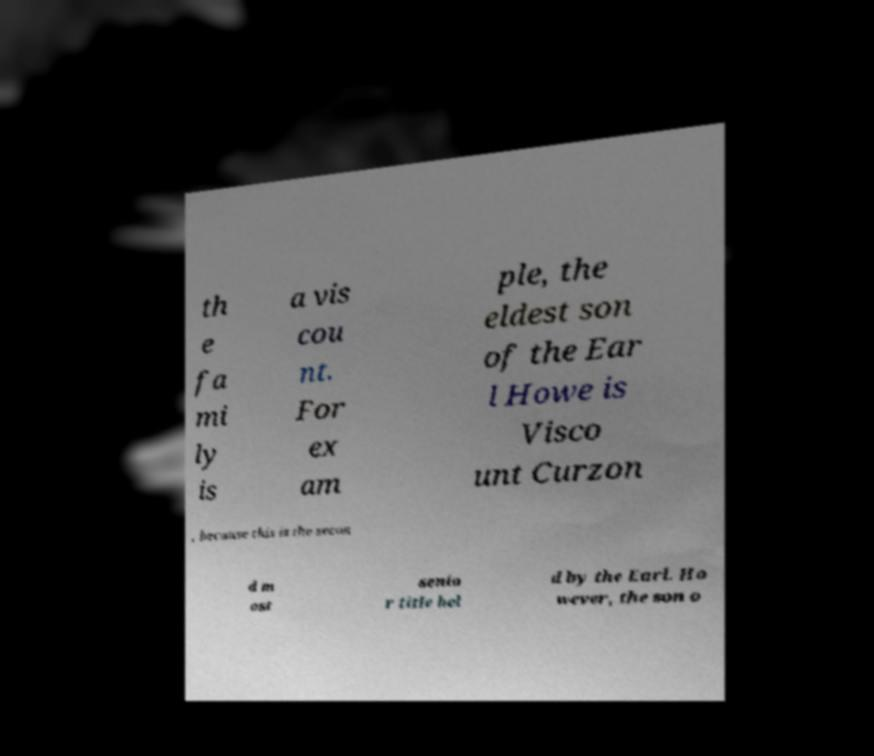Can you read and provide the text displayed in the image?This photo seems to have some interesting text. Can you extract and type it out for me? th e fa mi ly is a vis cou nt. For ex am ple, the eldest son of the Ear l Howe is Visco unt Curzon , because this is the secon d m ost senio r title hel d by the Earl. Ho wever, the son o 